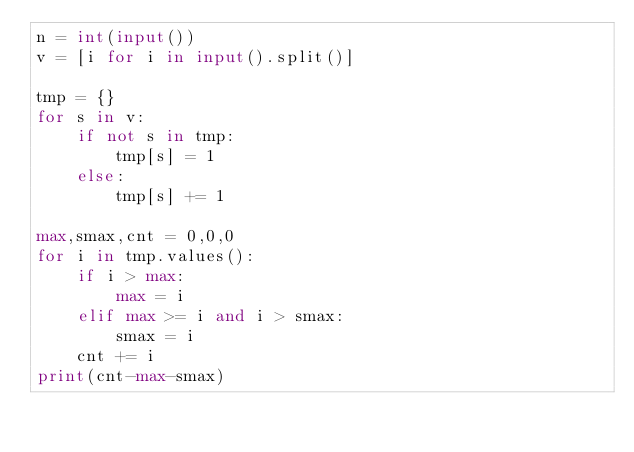<code> <loc_0><loc_0><loc_500><loc_500><_Python_>n = int(input())
v = [i for i in input().split()]

tmp = {}
for s in v:
    if not s in tmp:
        tmp[s] = 1
    else:
        tmp[s] += 1

max,smax,cnt = 0,0,0
for i in tmp.values():
    if i > max:
        max = i
    elif max >= i and i > smax:
        smax = i
    cnt += i
print(cnt-max-smax)
</code> 